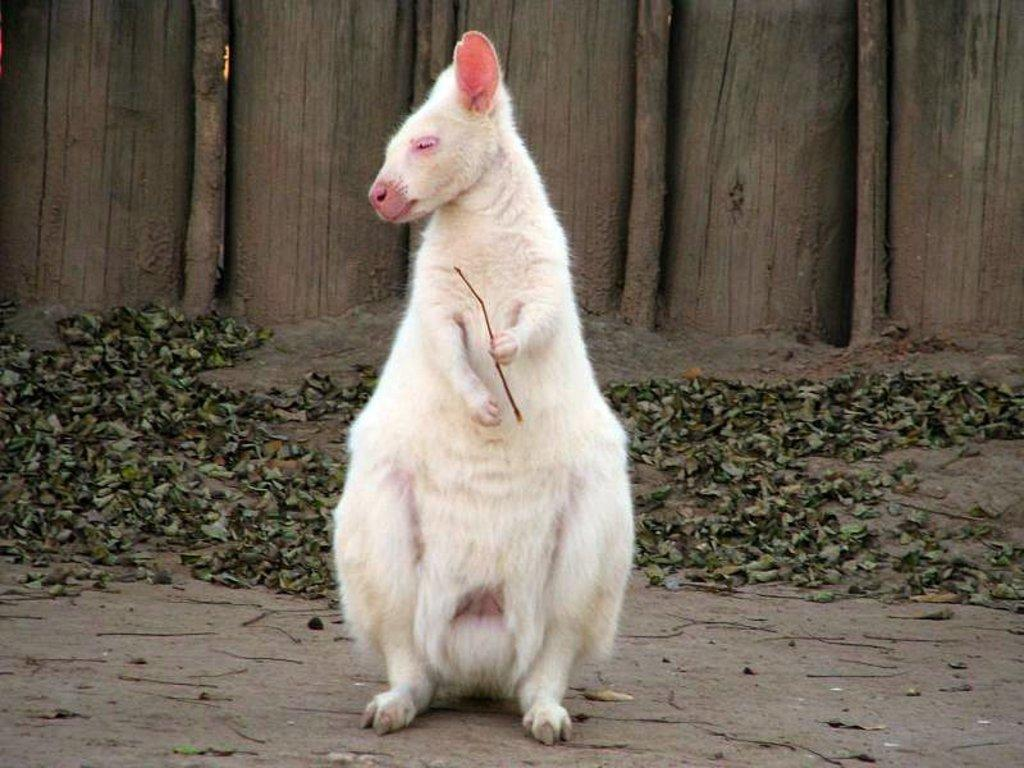What type of animal can be seen in the image? There is an animal in the image, but its specific type cannot be determined from the provided facts. What is the animal doing in the image? The animal is standing and holding a stick in the image. What color is the stick that the animal is holding? The stick is white in color. What can be seen in the background of the image? There are trees visible in the background of the image. What is present at the bottom of the image? Dried leaves are present at the bottom of the image. What type of throat medicine is the animal taking in the image? There is no indication in the image that the animal is taking any throat medicine. 